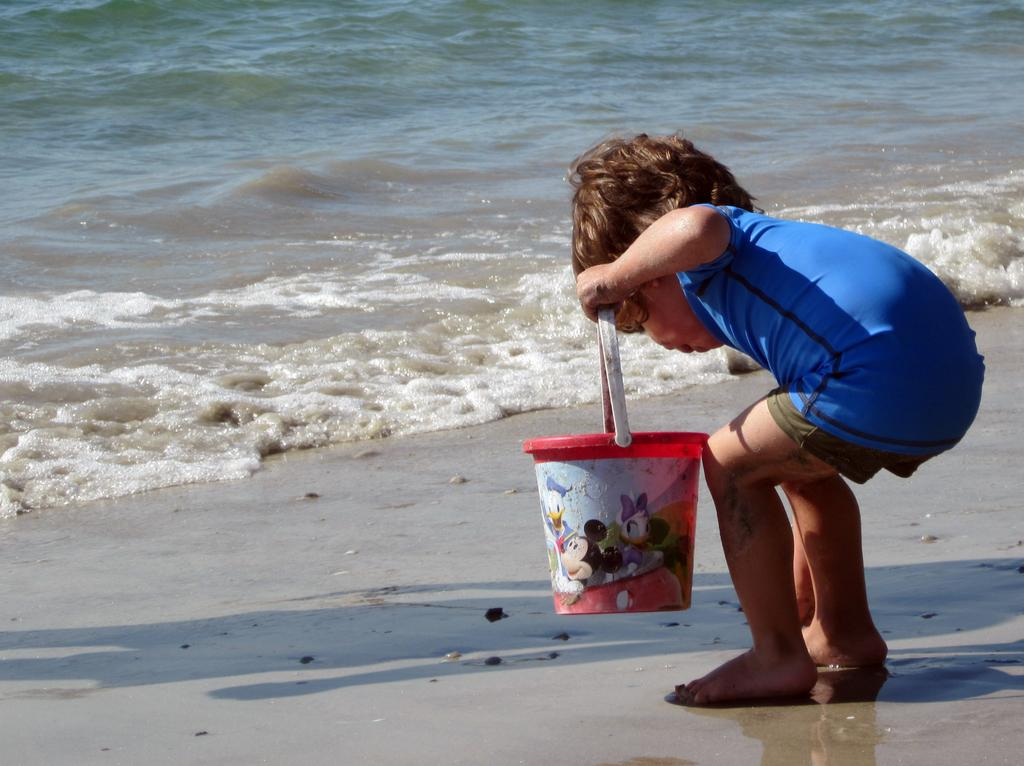What is the main subject of the image? There is a child in the image. Where is the child located? The child is standing on the seashore. What is the child holding in the image? The child is holding a bucket. What can be seen in the background of the image? There are stones and water visible in the image. What type of quartz can be seen on the desk in the image? There is no desk or quartz present in the image. What is the child's afterthought while standing on the seashore? The image does not provide information about the child's thoughts or afterthoughts. 